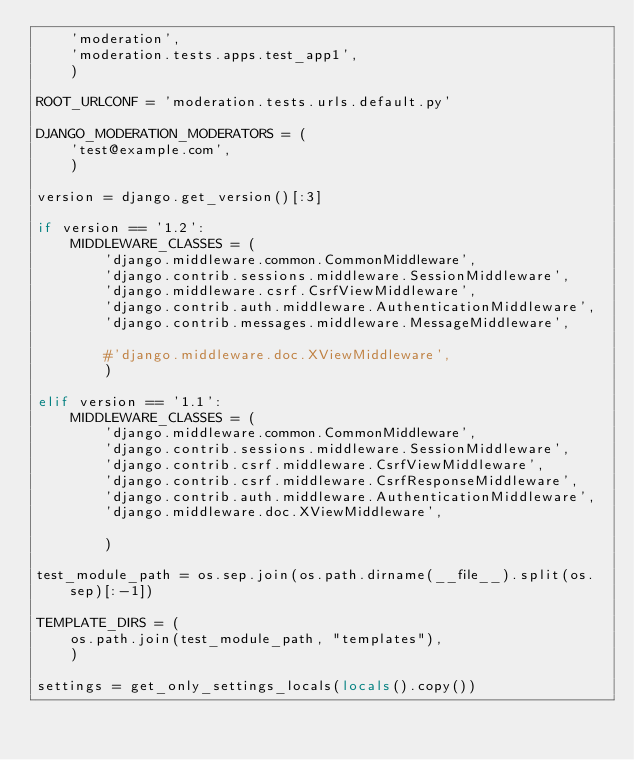<code> <loc_0><loc_0><loc_500><loc_500><_Python_>    'moderation',
    'moderation.tests.apps.test_app1',
    )

ROOT_URLCONF = 'moderation.tests.urls.default.py'

DJANGO_MODERATION_MODERATORS = (
    'test@example.com',
    )

version = django.get_version()[:3]

if version == '1.2':
    MIDDLEWARE_CLASSES = (
        'django.middleware.common.CommonMiddleware',
        'django.contrib.sessions.middleware.SessionMiddleware',
        'django.middleware.csrf.CsrfViewMiddleware',
        'django.contrib.auth.middleware.AuthenticationMiddleware',
        'django.contrib.messages.middleware.MessageMiddleware',

        #'django.middleware.doc.XViewMiddleware',
        )

elif version == '1.1':
    MIDDLEWARE_CLASSES = (
        'django.middleware.common.CommonMiddleware',
        'django.contrib.sessions.middleware.SessionMiddleware',
        'django.contrib.csrf.middleware.CsrfViewMiddleware',
        'django.contrib.csrf.middleware.CsrfResponseMiddleware',
        'django.contrib.auth.middleware.AuthenticationMiddleware',
        'django.middleware.doc.XViewMiddleware',

        )

test_module_path = os.sep.join(os.path.dirname(__file__).split(os.sep)[:-1])

TEMPLATE_DIRS = (
    os.path.join(test_module_path, "templates"),
    )

settings = get_only_settings_locals(locals().copy())
</code> 